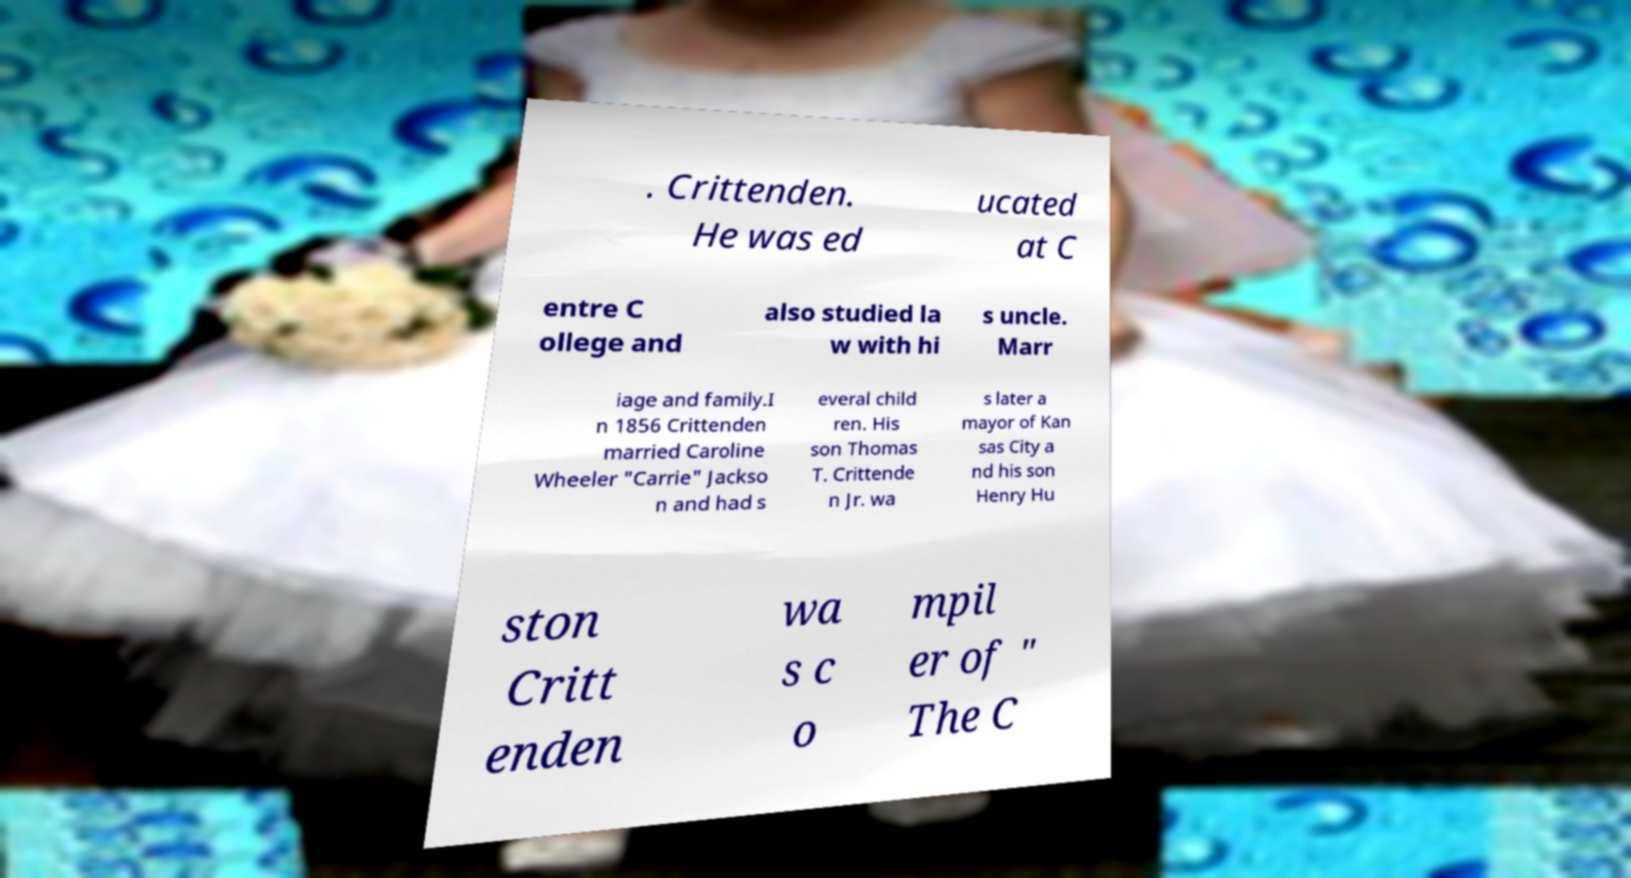Please identify and transcribe the text found in this image. . Crittenden. He was ed ucated at C entre C ollege and also studied la w with hi s uncle. Marr iage and family.I n 1856 Crittenden married Caroline Wheeler "Carrie" Jackso n and had s everal child ren. His son Thomas T. Crittende n Jr. wa s later a mayor of Kan sas City a nd his son Henry Hu ston Critt enden wa s c o mpil er of " The C 